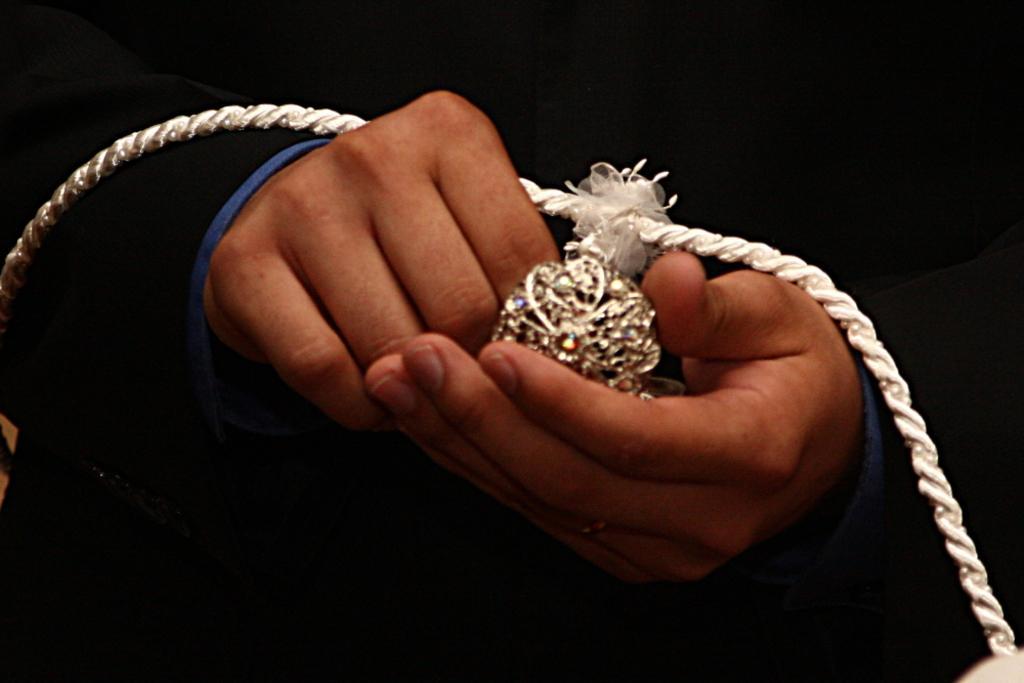Can you describe this image briefly? There is a person in the center of the image, it seems like holding a locket in his hands. 